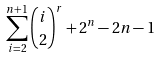Convert formula to latex. <formula><loc_0><loc_0><loc_500><loc_500>\sum _ { i = 2 } ^ { n + 1 } { i \choose 2 } ^ { r } + 2 ^ { n } - 2 n - 1</formula> 